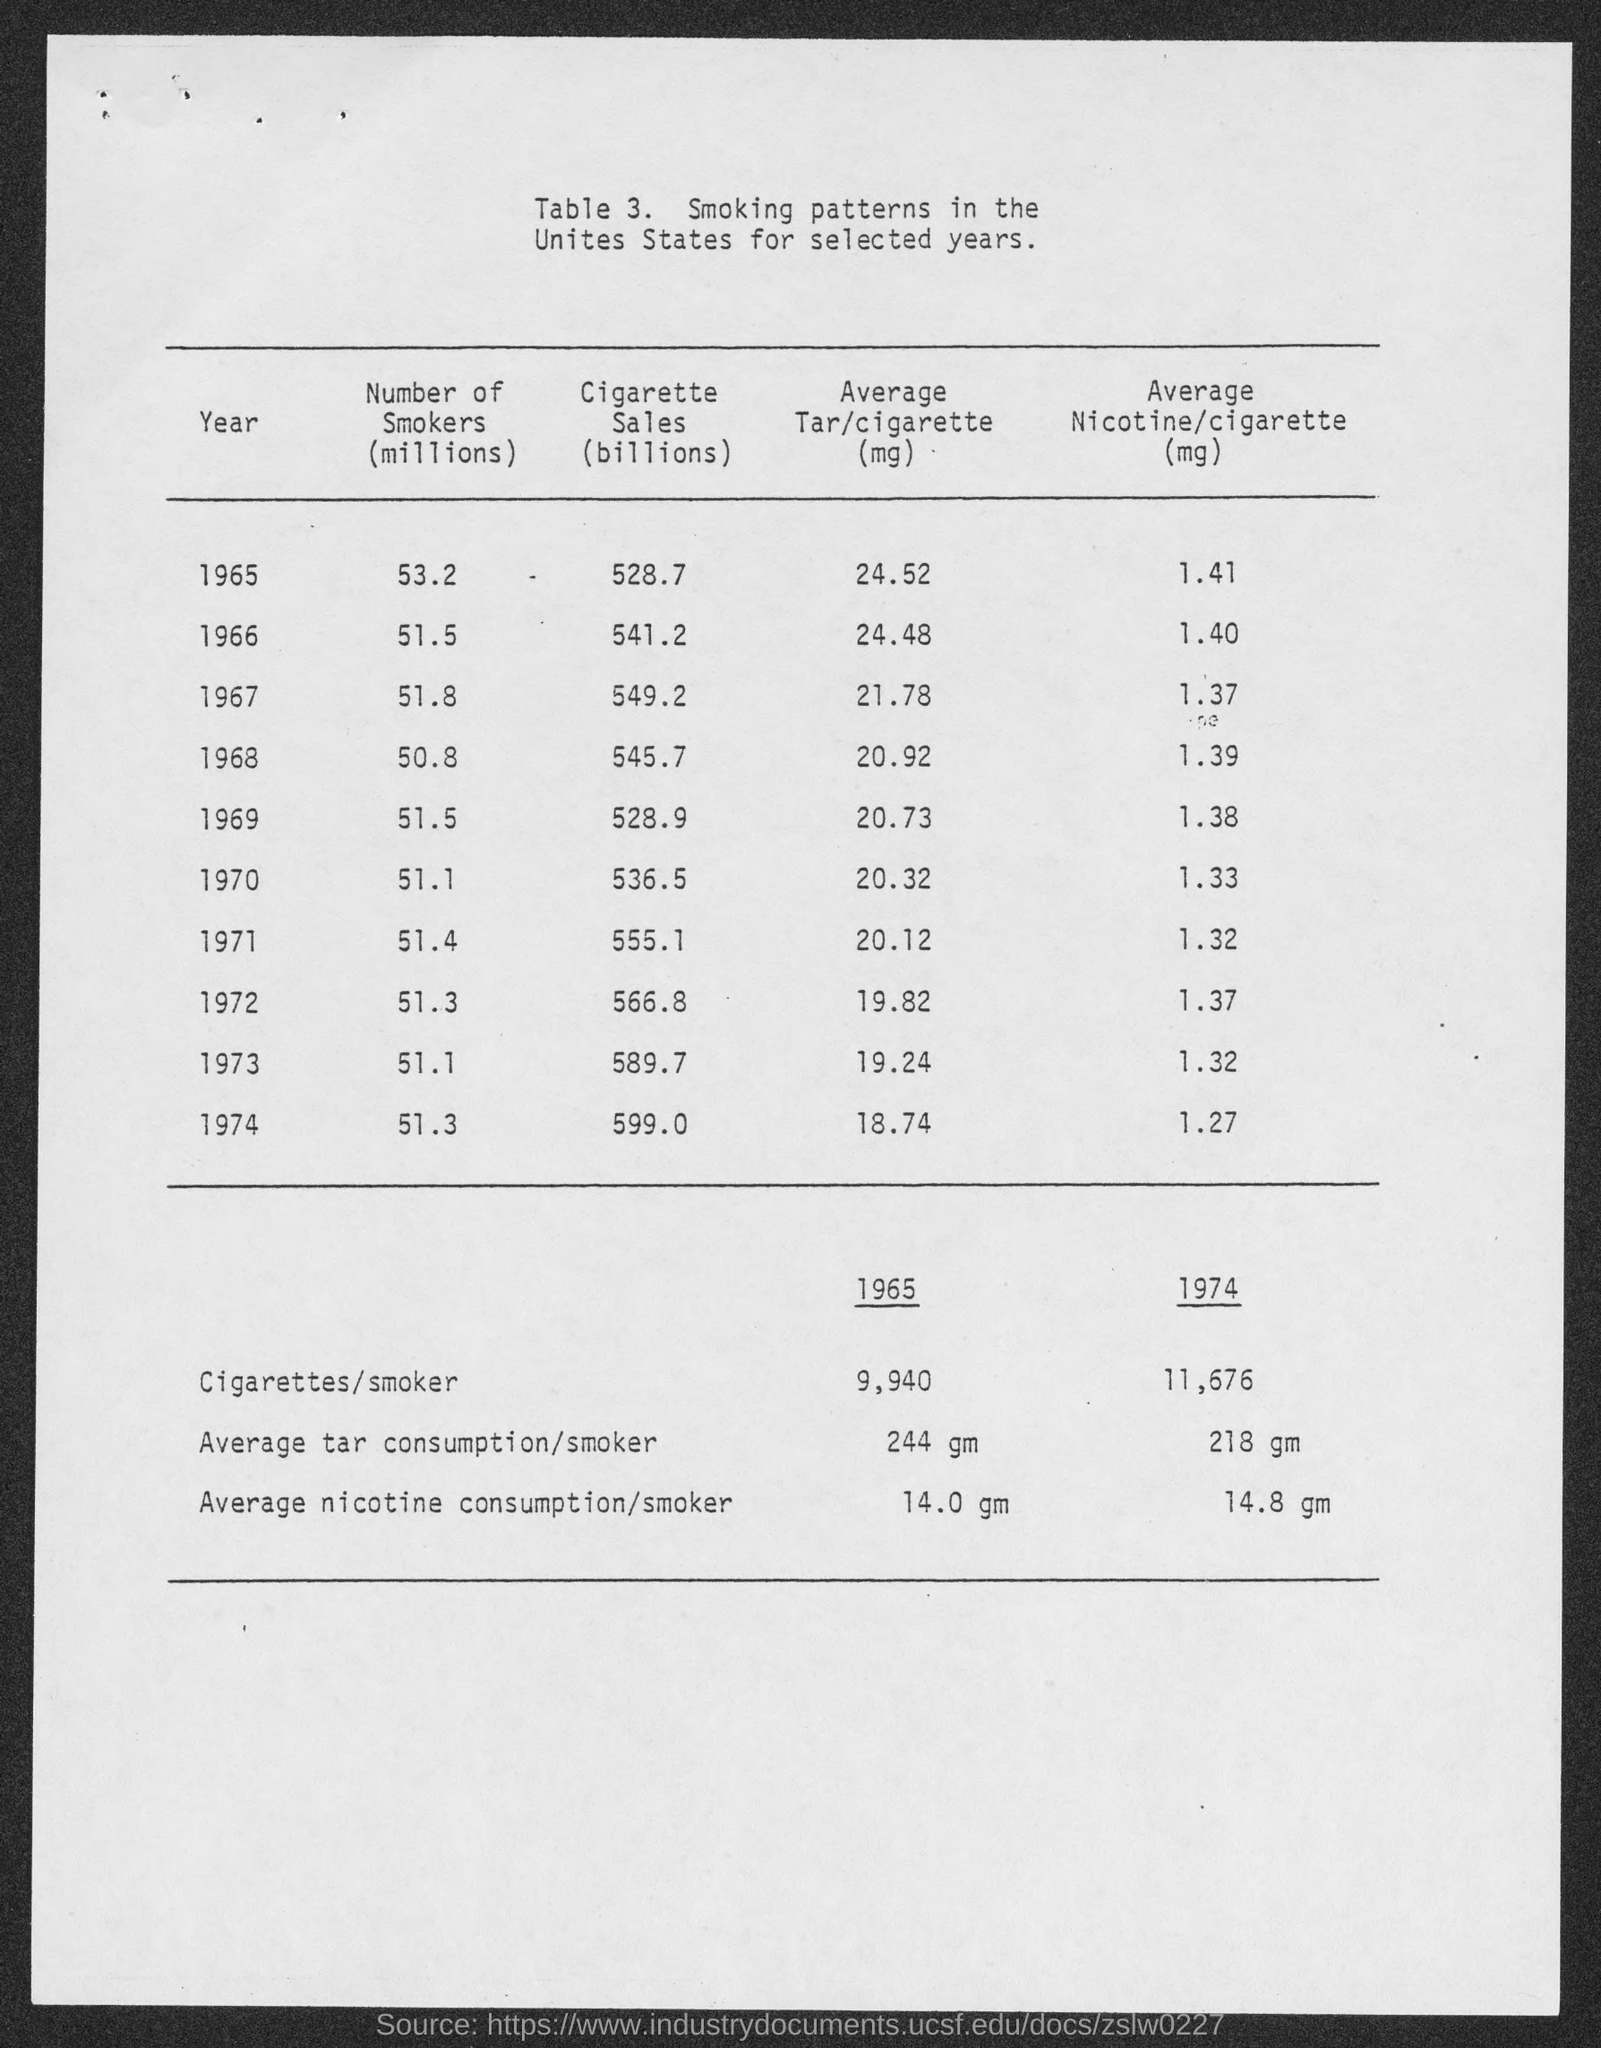Point out several critical features in this image. In 1968, there were approximately 50.8 million smokers in the United States. In 1966, there were approximately 51.5 million smokers in the world. In 1965, there were approximately 53.2 million smokers in the world. In 1974, there were approximately 51.3 million smokers in the world. In 1973, there were approximately 51.1 million smokers in the world. 